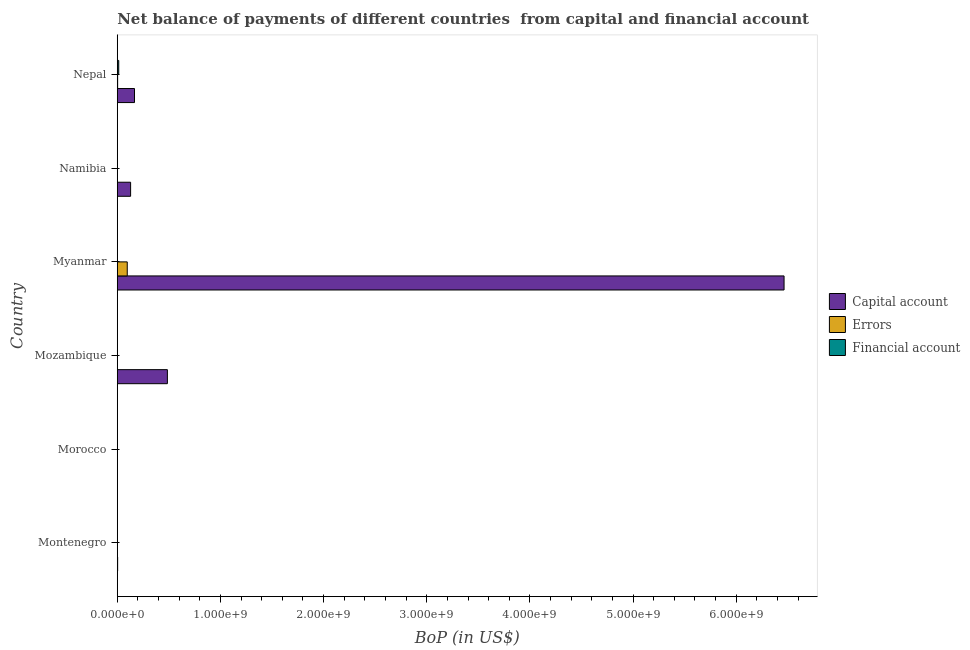Are the number of bars per tick equal to the number of legend labels?
Offer a very short reply. No. How many bars are there on the 1st tick from the bottom?
Your answer should be compact. 1. What is the label of the 5th group of bars from the top?
Keep it short and to the point. Morocco. In how many cases, is the number of bars for a given country not equal to the number of legend labels?
Offer a terse response. 5. What is the amount of errors in Nepal?
Ensure brevity in your answer.  3.55e+06. Across all countries, what is the maximum amount of financial account?
Provide a short and direct response. 1.41e+07. In which country was the amount of financial account maximum?
Make the answer very short. Nepal. What is the total amount of net capital account in the graph?
Your answer should be very brief. 7.25e+09. What is the difference between the amount of net capital account in Mozambique and that in Nepal?
Offer a very short reply. 3.19e+08. What is the difference between the amount of financial account in Mozambique and the amount of errors in Myanmar?
Give a very brief answer. -9.66e+07. What is the average amount of errors per country?
Ensure brevity in your answer.  1.67e+07. What is the difference between the amount of financial account and amount of errors in Nepal?
Give a very brief answer. 1.06e+07. What is the ratio of the amount of net capital account in Myanmar to that in Namibia?
Offer a very short reply. 50.02. What is the difference between the highest and the second highest amount of net capital account?
Give a very brief answer. 5.98e+09. What is the difference between the highest and the lowest amount of net capital account?
Offer a terse response. 6.46e+09. In how many countries, is the amount of errors greater than the average amount of errors taken over all countries?
Give a very brief answer. 1. How many bars are there?
Offer a terse response. 8. Are the values on the major ticks of X-axis written in scientific E-notation?
Provide a short and direct response. Yes. Does the graph contain any zero values?
Your answer should be compact. Yes. Does the graph contain grids?
Provide a short and direct response. No. Where does the legend appear in the graph?
Make the answer very short. Center right. What is the title of the graph?
Make the answer very short. Net balance of payments of different countries  from capital and financial account. What is the label or title of the X-axis?
Keep it short and to the point. BoP (in US$). What is the BoP (in US$) of Capital account in Montenegro?
Provide a short and direct response. 3.47e+06. What is the BoP (in US$) in Errors in Montenegro?
Your response must be concise. 0. What is the BoP (in US$) of Capital account in Mozambique?
Provide a short and direct response. 4.86e+08. What is the BoP (in US$) in Errors in Mozambique?
Your answer should be compact. 0. What is the BoP (in US$) in Capital account in Myanmar?
Give a very brief answer. 6.46e+09. What is the BoP (in US$) in Errors in Myanmar?
Provide a succinct answer. 9.66e+07. What is the BoP (in US$) in Capital account in Namibia?
Offer a very short reply. 1.29e+08. What is the BoP (in US$) in Errors in Namibia?
Ensure brevity in your answer.  0. What is the BoP (in US$) of Capital account in Nepal?
Provide a succinct answer. 1.67e+08. What is the BoP (in US$) of Errors in Nepal?
Give a very brief answer. 3.55e+06. What is the BoP (in US$) of Financial account in Nepal?
Make the answer very short. 1.41e+07. Across all countries, what is the maximum BoP (in US$) of Capital account?
Provide a short and direct response. 6.46e+09. Across all countries, what is the maximum BoP (in US$) of Errors?
Provide a succinct answer. 9.66e+07. Across all countries, what is the maximum BoP (in US$) in Financial account?
Your answer should be compact. 1.41e+07. Across all countries, what is the minimum BoP (in US$) of Capital account?
Provide a succinct answer. 0. Across all countries, what is the minimum BoP (in US$) of Financial account?
Your answer should be very brief. 0. What is the total BoP (in US$) of Capital account in the graph?
Provide a short and direct response. 7.25e+09. What is the total BoP (in US$) of Errors in the graph?
Provide a short and direct response. 1.00e+08. What is the total BoP (in US$) of Financial account in the graph?
Offer a very short reply. 1.41e+07. What is the difference between the BoP (in US$) of Capital account in Montenegro and that in Mozambique?
Your answer should be very brief. -4.82e+08. What is the difference between the BoP (in US$) in Capital account in Montenegro and that in Myanmar?
Your answer should be compact. -6.46e+09. What is the difference between the BoP (in US$) in Capital account in Montenegro and that in Namibia?
Offer a terse response. -1.26e+08. What is the difference between the BoP (in US$) in Capital account in Montenegro and that in Nepal?
Give a very brief answer. -1.63e+08. What is the difference between the BoP (in US$) of Capital account in Mozambique and that in Myanmar?
Keep it short and to the point. -5.98e+09. What is the difference between the BoP (in US$) in Capital account in Mozambique and that in Namibia?
Your answer should be very brief. 3.57e+08. What is the difference between the BoP (in US$) in Capital account in Mozambique and that in Nepal?
Offer a very short reply. 3.19e+08. What is the difference between the BoP (in US$) in Capital account in Myanmar and that in Namibia?
Make the answer very short. 6.33e+09. What is the difference between the BoP (in US$) in Capital account in Myanmar and that in Nepal?
Offer a terse response. 6.30e+09. What is the difference between the BoP (in US$) of Errors in Myanmar and that in Nepal?
Your answer should be compact. 9.30e+07. What is the difference between the BoP (in US$) of Capital account in Namibia and that in Nepal?
Make the answer very short. -3.77e+07. What is the difference between the BoP (in US$) in Capital account in Montenegro and the BoP (in US$) in Errors in Myanmar?
Give a very brief answer. -9.31e+07. What is the difference between the BoP (in US$) in Capital account in Montenegro and the BoP (in US$) in Errors in Nepal?
Your answer should be very brief. -7.90e+04. What is the difference between the BoP (in US$) of Capital account in Montenegro and the BoP (in US$) of Financial account in Nepal?
Your response must be concise. -1.07e+07. What is the difference between the BoP (in US$) of Capital account in Mozambique and the BoP (in US$) of Errors in Myanmar?
Your answer should be compact. 3.89e+08. What is the difference between the BoP (in US$) of Capital account in Mozambique and the BoP (in US$) of Errors in Nepal?
Make the answer very short. 4.82e+08. What is the difference between the BoP (in US$) of Capital account in Mozambique and the BoP (in US$) of Financial account in Nepal?
Ensure brevity in your answer.  4.72e+08. What is the difference between the BoP (in US$) of Capital account in Myanmar and the BoP (in US$) of Errors in Nepal?
Your response must be concise. 6.46e+09. What is the difference between the BoP (in US$) in Capital account in Myanmar and the BoP (in US$) in Financial account in Nepal?
Offer a terse response. 6.45e+09. What is the difference between the BoP (in US$) of Errors in Myanmar and the BoP (in US$) of Financial account in Nepal?
Offer a terse response. 8.24e+07. What is the difference between the BoP (in US$) of Capital account in Namibia and the BoP (in US$) of Errors in Nepal?
Your answer should be very brief. 1.26e+08. What is the difference between the BoP (in US$) in Capital account in Namibia and the BoP (in US$) in Financial account in Nepal?
Your answer should be compact. 1.15e+08. What is the average BoP (in US$) of Capital account per country?
Your answer should be compact. 1.21e+09. What is the average BoP (in US$) in Errors per country?
Make the answer very short. 1.67e+07. What is the average BoP (in US$) of Financial account per country?
Offer a terse response. 2.36e+06. What is the difference between the BoP (in US$) in Capital account and BoP (in US$) in Errors in Myanmar?
Your answer should be compact. 6.37e+09. What is the difference between the BoP (in US$) in Capital account and BoP (in US$) in Errors in Nepal?
Give a very brief answer. 1.63e+08. What is the difference between the BoP (in US$) of Capital account and BoP (in US$) of Financial account in Nepal?
Your response must be concise. 1.53e+08. What is the difference between the BoP (in US$) of Errors and BoP (in US$) of Financial account in Nepal?
Provide a succinct answer. -1.06e+07. What is the ratio of the BoP (in US$) in Capital account in Montenegro to that in Mozambique?
Ensure brevity in your answer.  0.01. What is the ratio of the BoP (in US$) of Capital account in Montenegro to that in Namibia?
Provide a succinct answer. 0.03. What is the ratio of the BoP (in US$) of Capital account in Montenegro to that in Nepal?
Give a very brief answer. 0.02. What is the ratio of the BoP (in US$) in Capital account in Mozambique to that in Myanmar?
Offer a very short reply. 0.08. What is the ratio of the BoP (in US$) of Capital account in Mozambique to that in Namibia?
Give a very brief answer. 3.76. What is the ratio of the BoP (in US$) in Capital account in Mozambique to that in Nepal?
Your response must be concise. 2.91. What is the ratio of the BoP (in US$) in Capital account in Myanmar to that in Namibia?
Your answer should be compact. 50.02. What is the ratio of the BoP (in US$) of Capital account in Myanmar to that in Nepal?
Give a very brief answer. 38.72. What is the ratio of the BoP (in US$) of Errors in Myanmar to that in Nepal?
Provide a succinct answer. 27.19. What is the ratio of the BoP (in US$) in Capital account in Namibia to that in Nepal?
Ensure brevity in your answer.  0.77. What is the difference between the highest and the second highest BoP (in US$) in Capital account?
Ensure brevity in your answer.  5.98e+09. What is the difference between the highest and the lowest BoP (in US$) in Capital account?
Provide a short and direct response. 6.46e+09. What is the difference between the highest and the lowest BoP (in US$) in Errors?
Offer a terse response. 9.66e+07. What is the difference between the highest and the lowest BoP (in US$) in Financial account?
Ensure brevity in your answer.  1.41e+07. 